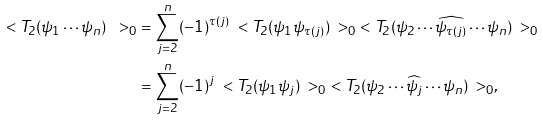<formula> <loc_0><loc_0><loc_500><loc_500>\ < T _ { 2 } ( \psi _ { 1 } \cdots \psi _ { n } ) \ > _ { 0 } & = \sum _ { j = 2 } ^ { n } ( - 1 ) ^ { \tau ( j ) } \ < T _ { 2 } ( \psi _ { 1 } \psi _ { \tau ( j ) } ) \ > _ { 0 } \ < T _ { 2 } ( \psi _ { 2 } \cdots \widehat { \psi _ { \tau ( j ) } } \cdots \psi _ { n } ) \ > _ { 0 } \\ & = \sum _ { j = 2 } ^ { n } ( - 1 ) ^ { j } \ < T _ { 2 } ( \psi _ { 1 } \psi _ { j } ) \ > _ { 0 } \ < T _ { 2 } ( \psi _ { 2 } \cdots \widehat { \psi _ { j } } \cdots \psi _ { n } ) \ > _ { 0 } ,</formula> 